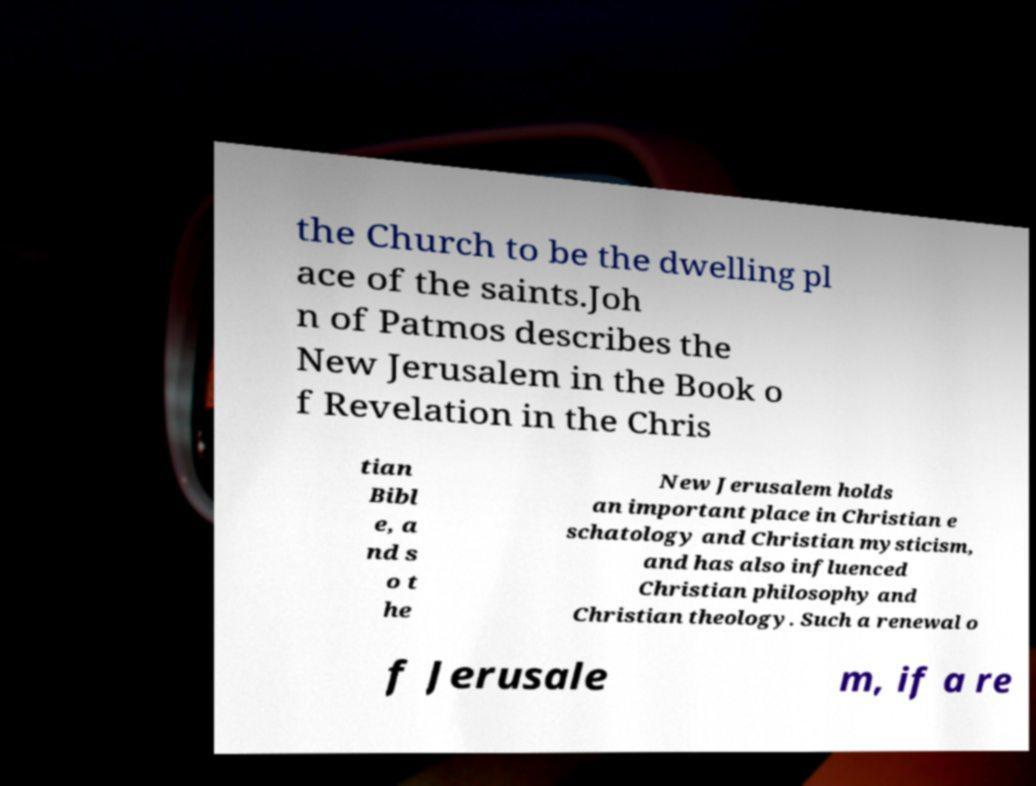Can you read and provide the text displayed in the image?This photo seems to have some interesting text. Can you extract and type it out for me? the Church to be the dwelling pl ace of the saints.Joh n of Patmos describes the New Jerusalem in the Book o f Revelation in the Chris tian Bibl e, a nd s o t he New Jerusalem holds an important place in Christian e schatology and Christian mysticism, and has also influenced Christian philosophy and Christian theology. Such a renewal o f Jerusale m, if a re 